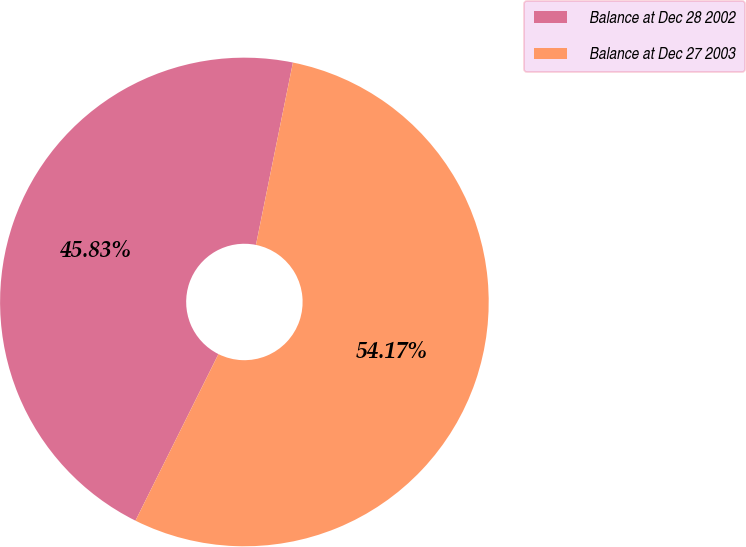Convert chart to OTSL. <chart><loc_0><loc_0><loc_500><loc_500><pie_chart><fcel>Balance at Dec 28 2002<fcel>Balance at Dec 27 2003<nl><fcel>45.83%<fcel>54.17%<nl></chart> 